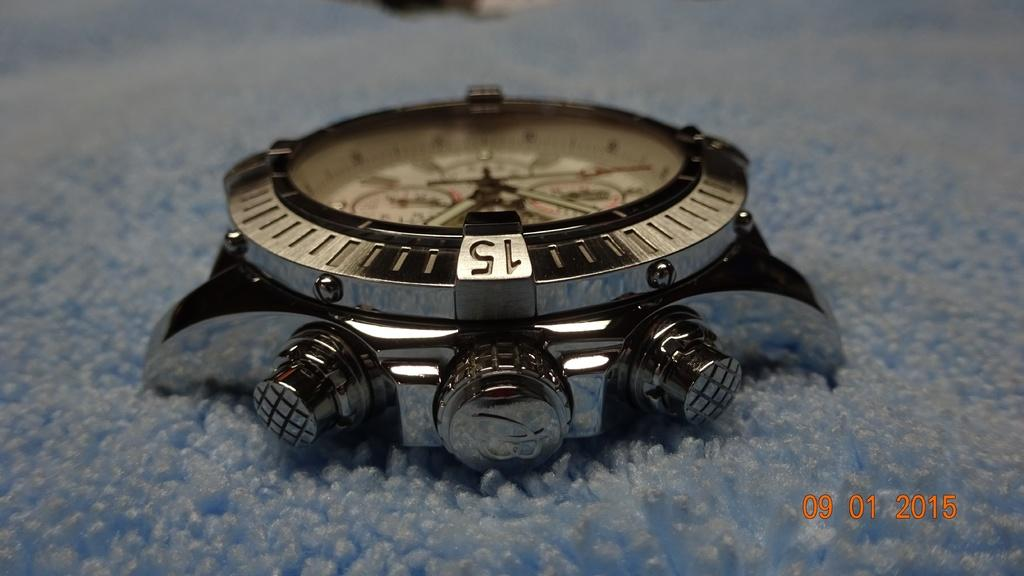Provide a one-sentence caption for the provided image. A watch with the number 15 written on top. 